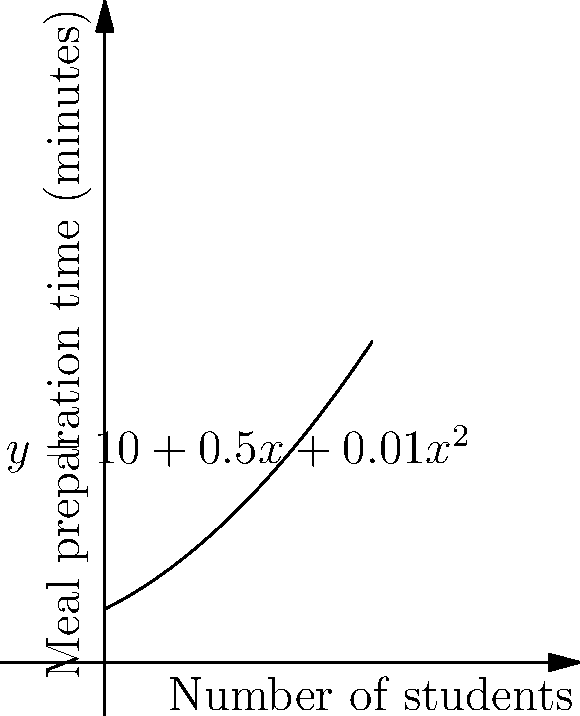In a school cafeteria, the meal preparation time (y) in minutes is related to the number of students (x) by the function $y = 10 + 0.5x + 0.01x^2$. Calculate the instantaneous rate of change in meal preparation time when there are 30 students. How does this relate to the cafeteria workers' efficiency? To find the instantaneous rate of change, we need to calculate the derivative of the function at x = 30.

1) The given function is $y = 10 + 0.5x + 0.01x^2$

2) To find the derivative, we use the power rule:
   $\frac{dy}{dx} = 0 + 0.5 + 0.02x$

3) Simplify:
   $\frac{dy}{dx} = 0.5 + 0.02x$

4) Now, we substitute x = 30:
   $\frac{dy}{dx}|_{x=30} = 0.5 + 0.02(30) = 0.5 + 0.6 = 1.1$

5) Interpret the result:
   The instantaneous rate of change is 1.1 minutes per student when there are 30 students.

This means that for each additional student beyond 30, the meal preparation time increases by approximately 1.1 minutes. This information is crucial for cafeteria workers to understand their workload and efficiency, and could be used to advocate for better working conditions or additional staff when student numbers increase.
Answer: 1.1 minutes per student 